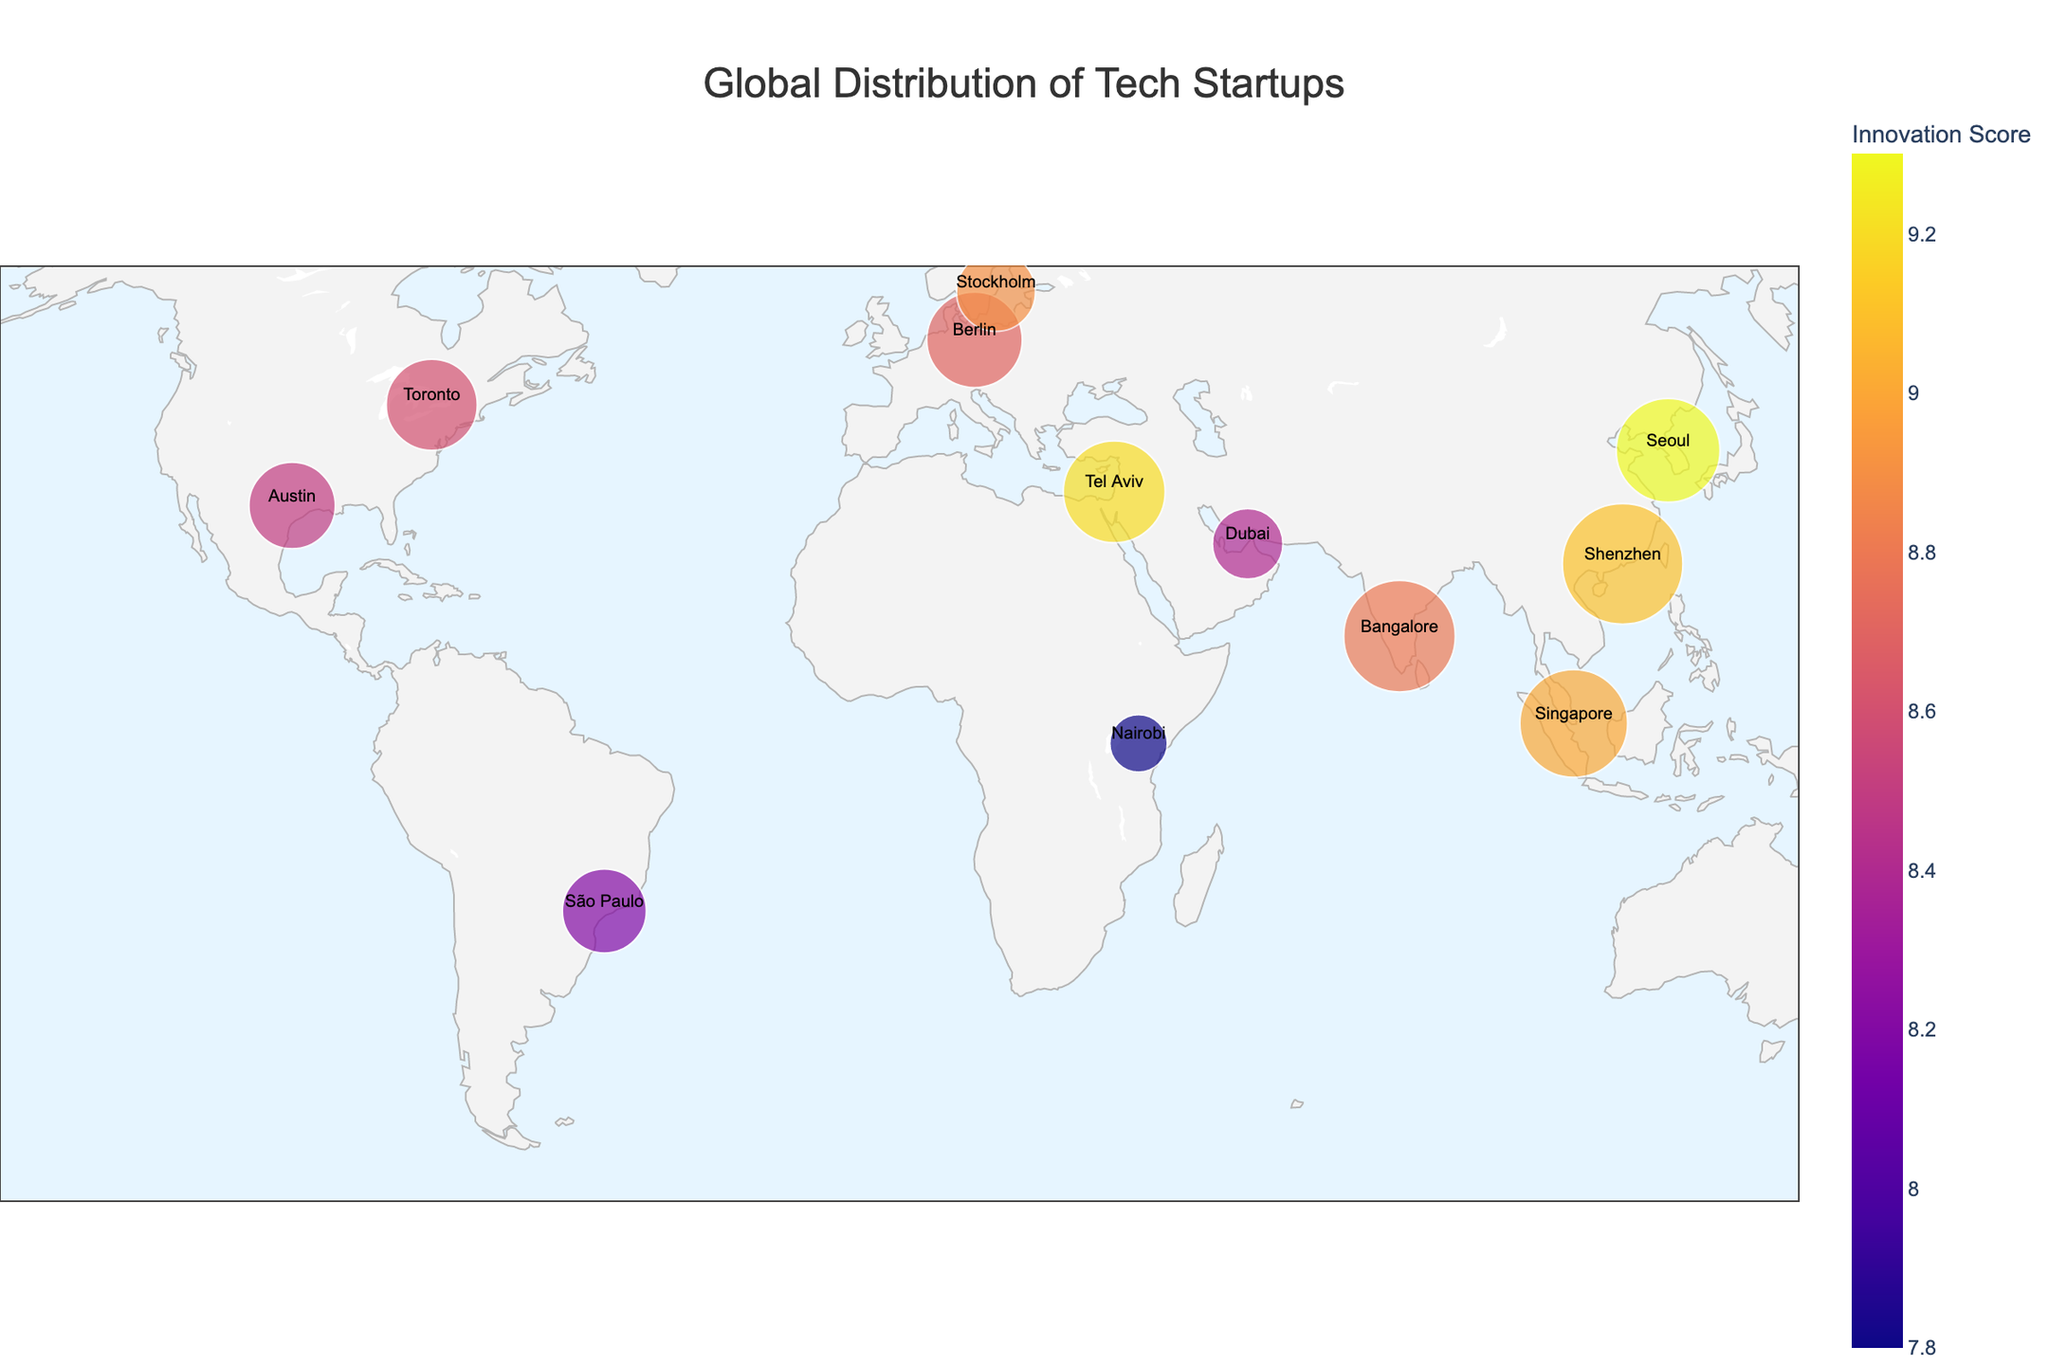What is the title of the plot? The title of the plot is positioned prominently at the top center of the figure.
Answer: Global Distribution of Tech Startups Which city has the highest number of tech startups? The cities are represented by varying circle sizes, so the largest circle indicates the highest number of startups. Upon inspection, Shenzhen has the largest circle.
Answer: Shenzhen Which city scores highest in innovation? The cities' innovation scores are color-coded on the plot. By identifying the city with the deepest color intensity, it indicates that Seoul scores highest.
Answer: Seoul What is the difference in the number of startups between Toronto and Austin? Locate both cities on the map and check the "Number of Startups" in their hover data. Toronto has 2000 startups, and Austin has 1800. Subtract 1800 from 2000.
Answer: 200 Which city has more startups, Tel Aviv or Bangalore? Compare the circle sizes of Tel Aviv and Bangalore. The hover data shows that Bangalore has 3000 startups and Tel Aviv has 2500. Bangalore has more startups.
Answer: Bangalore What is the average number of startups for cities in Asia? Identify the Asian cities (Tel Aviv, Bangalore, Singapore, Shenzhen, Seoul), then sum their numbers of startups and divide by the count. Tel Aviv (2500), Bangalore (3000), Singapore (2800), Shenzhen (3500), Seoul (2600). Total is 14400, and the average is 14400/5.
Answer: 2880 Which country is represented by Dubai? By locating Dubai on the plot and checking the corresponding hover data, it reveals the country name.
Answer: UAE Compare the innovation scores of Berlin and Stockholm. Which city has a higher score? Check the color intensity or refer to the hover data of Berlin and Stockholm. Berlin has an innovation score of 8.7, whereas Stockholm has a score of 8.9.
Answer: Stockholm How many cities have an innovation score above 9? Identify cities with colors indicating a score above 9 or check hover data. These cities are Tel Aviv, Singapore, Shenzhen, and Seoul. Count them.
Answer: 4 Which continent has the most represented cities in this plot? Observe cities on the map and their countries' continents. Count the number of cities per continent. Asia has the most represented cities.
Answer: Asia 